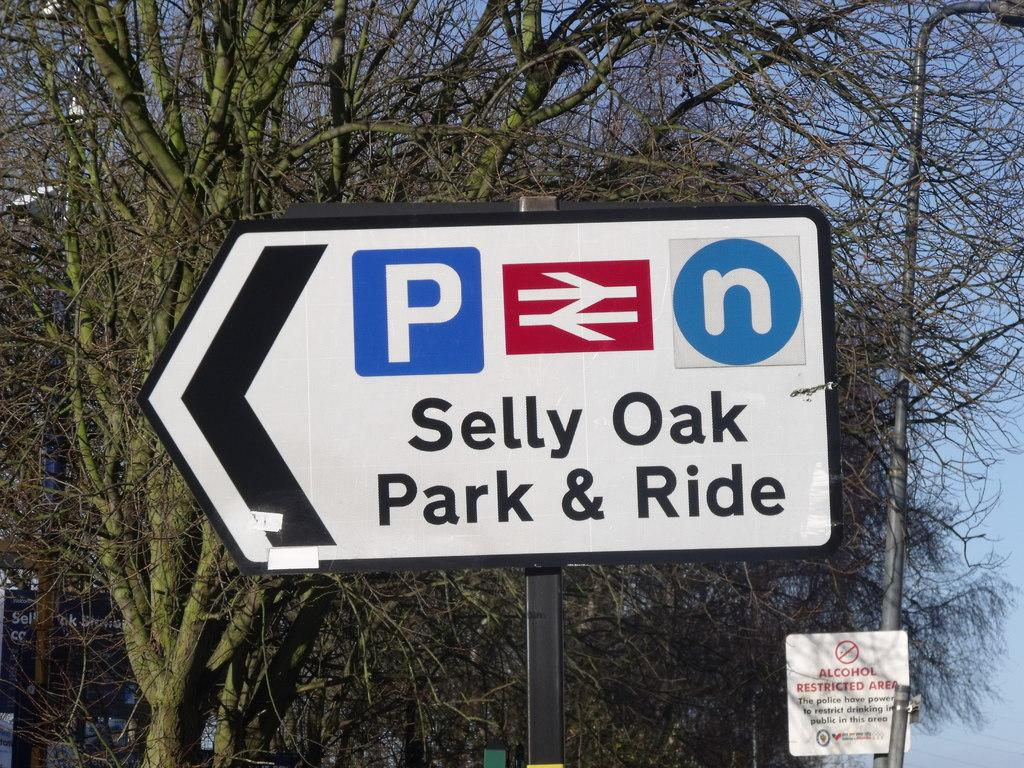<image>
Provide a brief description of the given image. An arrow shaped sign that says Selly oak park and ride. 